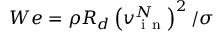Convert formula to latex. <formula><loc_0><loc_0><loc_500><loc_500>W e = \rho R _ { d } \left ( v _ { i n } ^ { N } \right ) ^ { 2 } / \sigma</formula> 